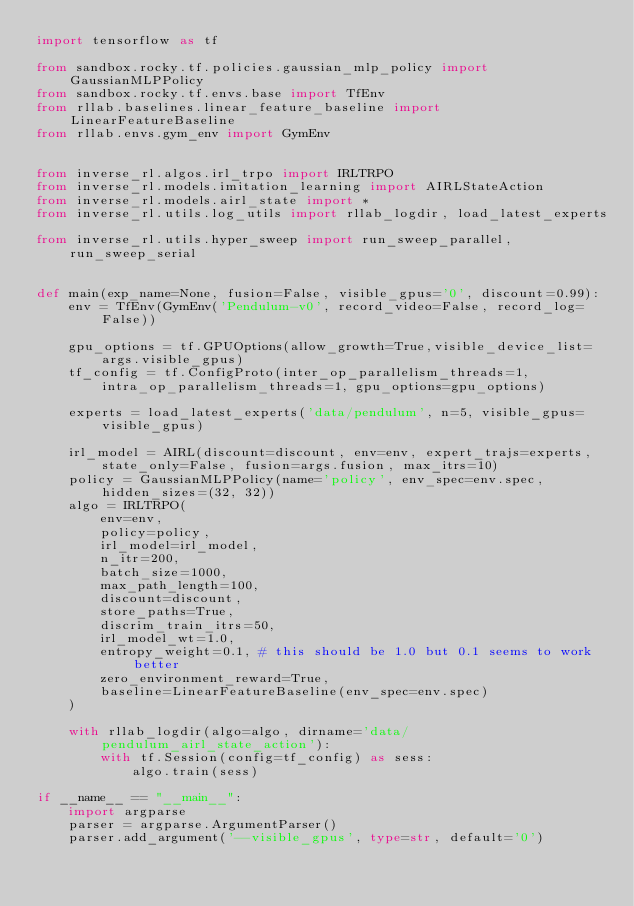Convert code to text. <code><loc_0><loc_0><loc_500><loc_500><_Python_>import tensorflow as tf

from sandbox.rocky.tf.policies.gaussian_mlp_policy import GaussianMLPPolicy
from sandbox.rocky.tf.envs.base import TfEnv
from rllab.baselines.linear_feature_baseline import LinearFeatureBaseline
from rllab.envs.gym_env import GymEnv


from inverse_rl.algos.irl_trpo import IRLTRPO
from inverse_rl.models.imitation_learning import AIRLStateAction
from inverse_rl.models.airl_state import *
from inverse_rl.utils.log_utils import rllab_logdir, load_latest_experts

from inverse_rl.utils.hyper_sweep import run_sweep_parallel, run_sweep_serial


def main(exp_name=None, fusion=False, visible_gpus='0', discount=0.99):
    env = TfEnv(GymEnv('Pendulum-v0', record_video=False, record_log=False))

    gpu_options = tf.GPUOptions(allow_growth=True,visible_device_list=args.visible_gpus)
    tf_config = tf.ConfigProto(inter_op_parallelism_threads=1, intra_op_parallelism_threads=1, gpu_options=gpu_options)

    experts = load_latest_experts('data/pendulum', n=5, visible_gpus=visible_gpus)

    irl_model = AIRL(discount=discount, env=env, expert_trajs=experts, state_only=False, fusion=args.fusion, max_itrs=10)
    policy = GaussianMLPPolicy(name='policy', env_spec=env.spec, hidden_sizes=(32, 32))
    algo = IRLTRPO(
        env=env,
        policy=policy,
        irl_model=irl_model,
        n_itr=200,
        batch_size=1000,
        max_path_length=100,
        discount=discount,
        store_paths=True,
        discrim_train_itrs=50,
        irl_model_wt=1.0,
        entropy_weight=0.1, # this should be 1.0 but 0.1 seems to work better
        zero_environment_reward=True,
        baseline=LinearFeatureBaseline(env_spec=env.spec)
    )

    with rllab_logdir(algo=algo, dirname='data/pendulum_airl_state_action'):
        with tf.Session(config=tf_config) as sess:
            algo.train(sess)

if __name__ == "__main__":
    import argparse
    parser = argparse.ArgumentParser()
    parser.add_argument('--visible_gpus', type=str, default='0')</code> 